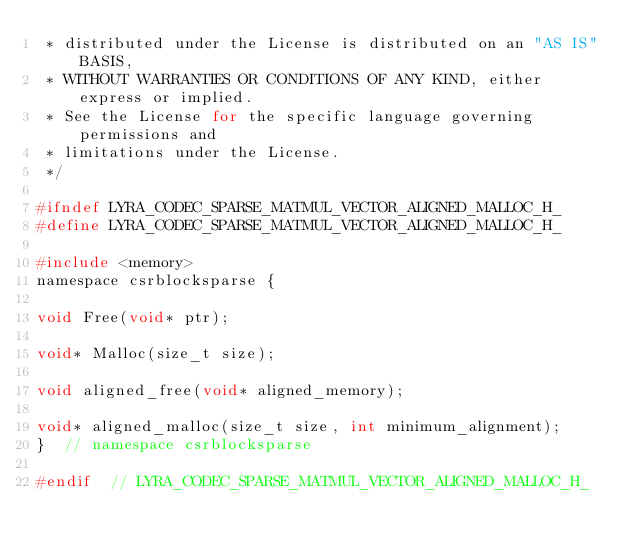Convert code to text. <code><loc_0><loc_0><loc_500><loc_500><_C_> * distributed under the License is distributed on an "AS IS" BASIS,
 * WITHOUT WARRANTIES OR CONDITIONS OF ANY KIND, either express or implied.
 * See the License for the specific language governing permissions and
 * limitations under the License.
 */

#ifndef LYRA_CODEC_SPARSE_MATMUL_VECTOR_ALIGNED_MALLOC_H_
#define LYRA_CODEC_SPARSE_MATMUL_VECTOR_ALIGNED_MALLOC_H_

#include <memory>
namespace csrblocksparse {

void Free(void* ptr);

void* Malloc(size_t size);

void aligned_free(void* aligned_memory);

void* aligned_malloc(size_t size, int minimum_alignment);
}  // namespace csrblocksparse

#endif  // LYRA_CODEC_SPARSE_MATMUL_VECTOR_ALIGNED_MALLOC_H_
</code> 